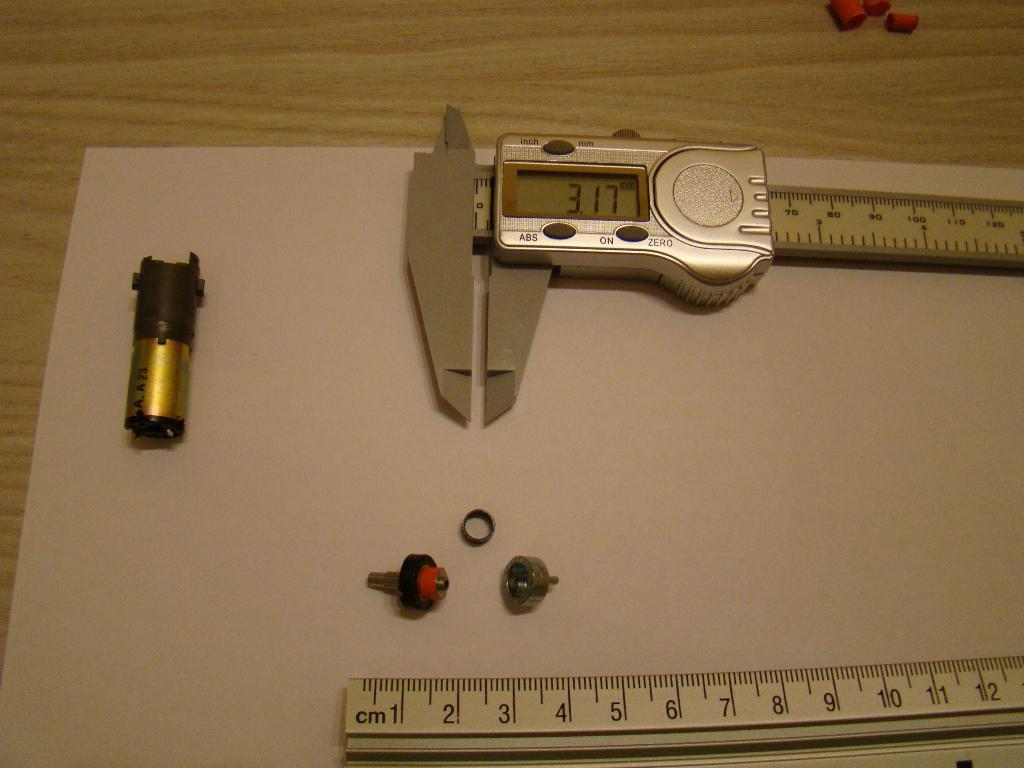<image>
Give a short and clear explanation of the subsequent image. A micrometer measures a part at 3.17 millimeters. 